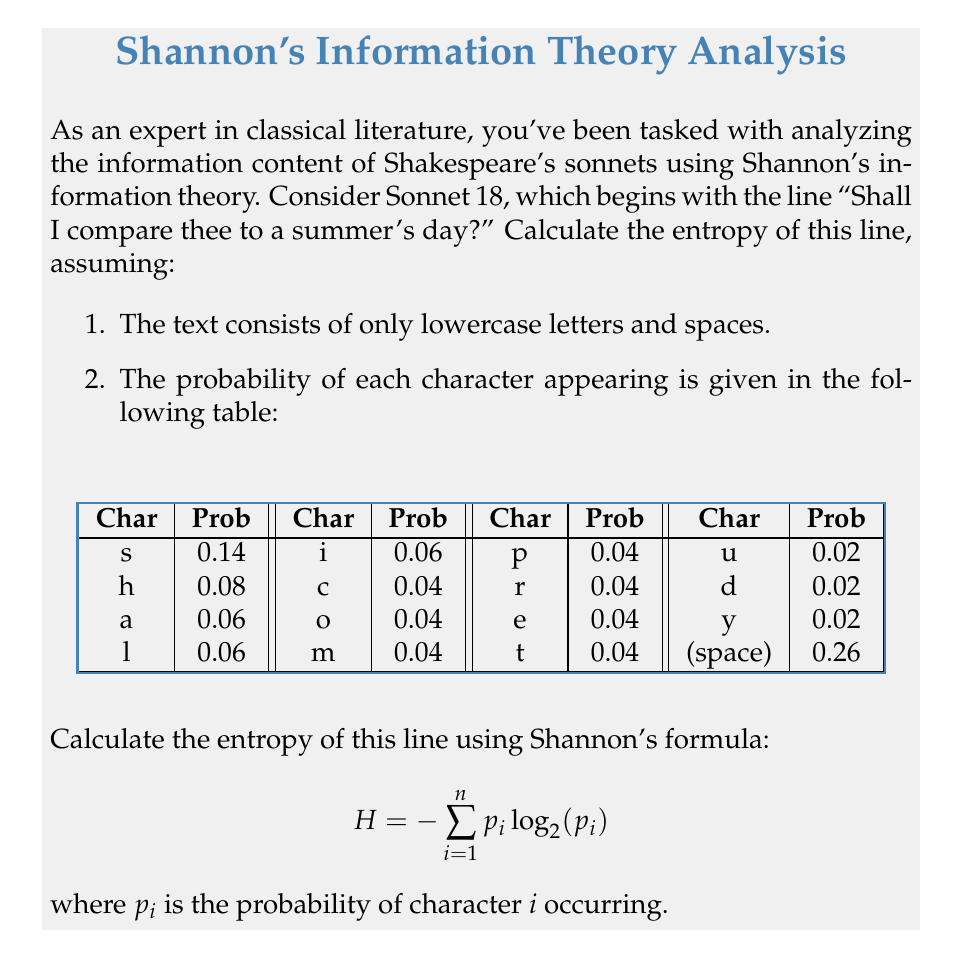Provide a solution to this math problem. To calculate the entropy of the given line using Shannon's formula, we need to follow these steps:

1. Identify the characters in the line:
   "shall i compare thee to a summer's day?"

2. Count the occurrences of each character:
   s: 3, h: 1, a: 3, l: 1, i: 1, c: 1, o: 1, m: 2, p: 1, r: 1, e: 2, t: 1, u: 1, d: 1, y: 1, space: 7

3. Use the given probabilities for each character:
   s: 0.14, h: 0.08, a: 0.06, l: 0.06, i: 0.06, c: 0.04, o: 0.04, m: 0.04, p: 0.04, r: 0.04, e: 0.04, t: 0.04, u: 0.02, d: 0.02, y: 0.02, space: 0.26

4. Apply Shannon's formula: $H = -\sum_{i=1}^n p_i \log_2(p_i)$

   $H = -[(0.14 \log_2(0.14)) + (0.08 \log_2(0.08)) + (0.06 \log_2(0.06)) + (0.06 \log_2(0.06)) + (0.06 \log_2(0.06)) + (0.04 \log_2(0.04)) + (0.04 \log_2(0.04)) + (0.04 \log_2(0.04)) + (0.04 \log_2(0.04)) + (0.04 \log_2(0.04)) + (0.04 \log_2(0.04)) + (0.04 \log_2(0.04)) + (0.02 \log_2(0.02)) + (0.02 \log_2(0.02)) + (0.02 \log_2(0.02)) + (0.26 \log_2(0.26))]$

5. Calculate each term:
   $0.14 \log_2(0.14) \approx -0.3979$
   $0.08 \log_2(0.08) \approx -0.2915$
   $0.06 \log_2(0.06) \approx -0.2441$
   $0.04 \log_2(0.04) \approx -0.1858$
   $0.02 \log_2(0.02) \approx -0.1129$
   $0.26 \log_2(0.26) \approx -0.5057$

6. Sum up all terms:
   $H = -[-0.3979 - 0.2915 - (3 \times -0.2441) - (7 \times -0.1858) - (3 \times -0.1129) - 0.5057]$

7. Calculate the final result:
   $H \approx 3.7242$ bits

This entropy value represents the average amount of information contained in each character of the given line from Shakespeare's Sonnet 18, based on the provided probability distribution.
Answer: $3.7242$ bits 